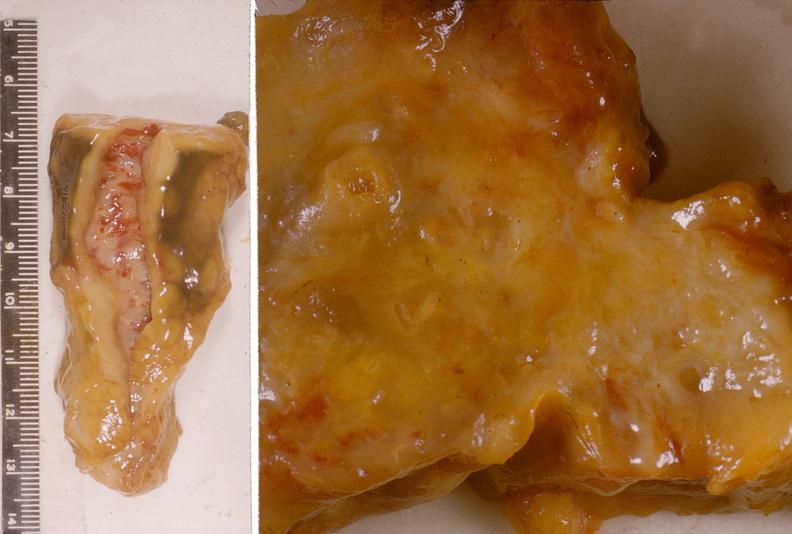does splenomegaly with cirrhosis show adenocarcinoma, head of pancreas?
Answer the question using a single word or phrase. No 